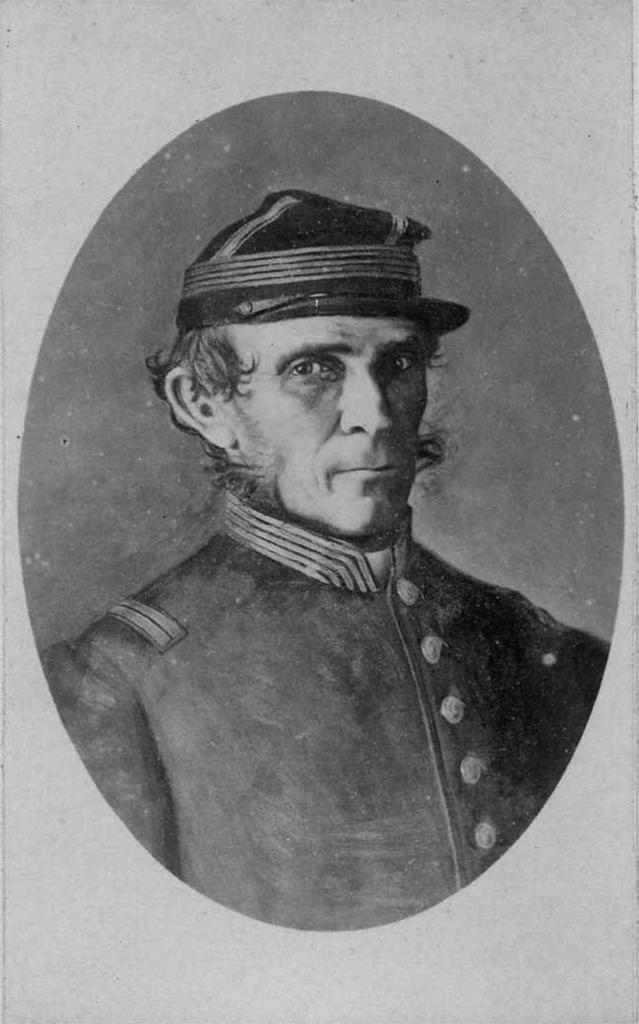What is the main subject of the image? The main subject of the image is a photo of a man. What is the man wearing in the photo? The man is wearing a cap in the photo. Is there a dog walking alongside the man in the photo? There is no dog present in the image, and the man is not walking. 